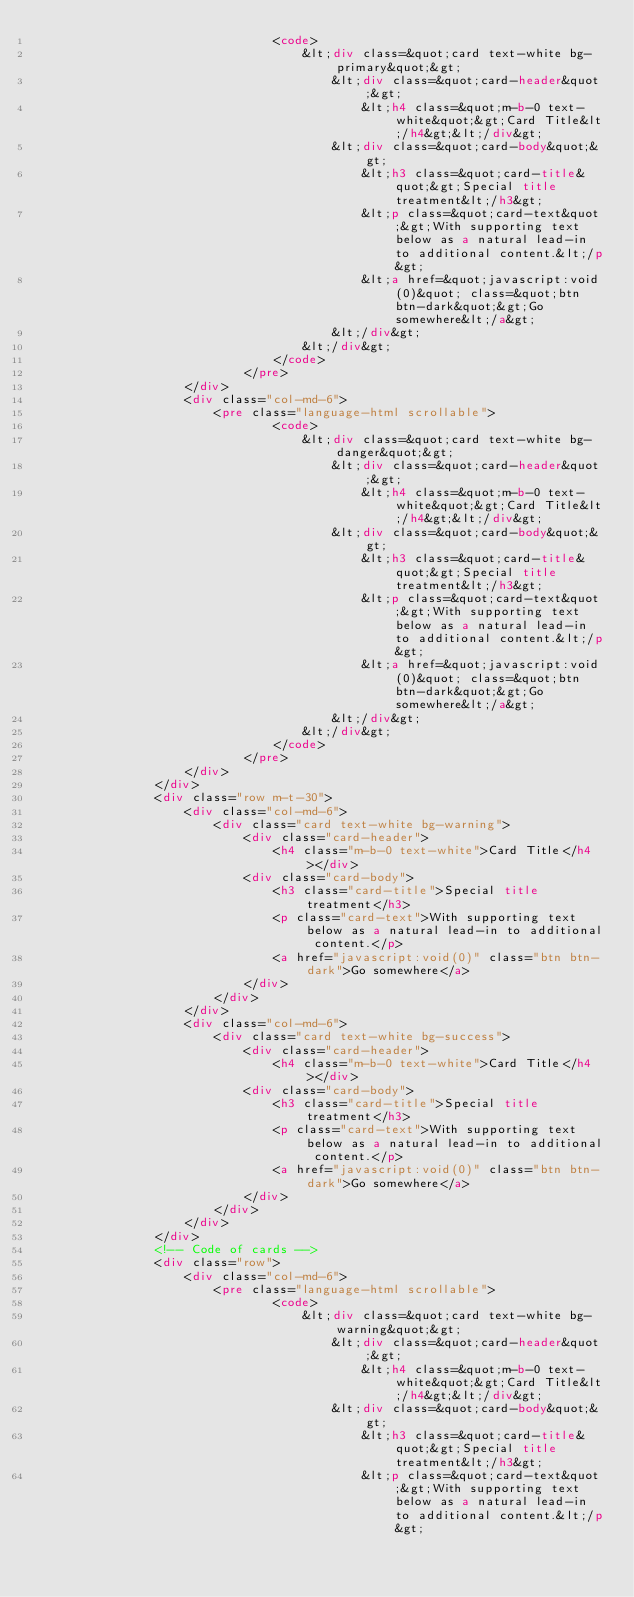Convert code to text. <code><loc_0><loc_0><loc_500><loc_500><_HTML_>                                <code>
                                    &lt;div class=&quot;card text-white bg-primary&quot;&gt;
                                        &lt;div class=&quot;card-header&quot;&gt;
                                            &lt;h4 class=&quot;m-b-0 text-white&quot;&gt;Card Title&lt;/h4&gt;&lt;/div&gt;
                                        &lt;div class=&quot;card-body&quot;&gt;
                                            &lt;h3 class=&quot;card-title&quot;&gt;Special title treatment&lt;/h3&gt;
                                            &lt;p class=&quot;card-text&quot;&gt;With supporting text below as a natural lead-in to additional content.&lt;/p&gt;
                                            &lt;a href=&quot;javascript:void(0)&quot; class=&quot;btn btn-dark&quot;&gt;Go somewhere&lt;/a&gt;
                                        &lt;/div&gt;
                                    &lt;/div&gt;
                                </code>
                            </pre>
                    </div>
                    <div class="col-md-6">
                        <pre class="language-html scrollable">
                                <code>
                                    &lt;div class=&quot;card text-white bg-danger&quot;&gt;
                                        &lt;div class=&quot;card-header&quot;&gt;
                                            &lt;h4 class=&quot;m-b-0 text-white&quot;&gt;Card Title&lt;/h4&gt;&lt;/div&gt;
                                        &lt;div class=&quot;card-body&quot;&gt;
                                            &lt;h3 class=&quot;card-title&quot;&gt;Special title treatment&lt;/h3&gt;
                                            &lt;p class=&quot;card-text&quot;&gt;With supporting text below as a natural lead-in to additional content.&lt;/p&gt;
                                            &lt;a href=&quot;javascript:void(0)&quot; class=&quot;btn btn-dark&quot;&gt;Go somewhere&lt;/a&gt;
                                        &lt;/div&gt;
                                    &lt;/div&gt;
                                </code>
                            </pre>
                    </div>
                </div>
                <div class="row m-t-30">
                    <div class="col-md-6">
                        <div class="card text-white bg-warning">
                            <div class="card-header">
                                <h4 class="m-b-0 text-white">Card Title</h4></div>
                            <div class="card-body">
                                <h3 class="card-title">Special title treatment</h3>
                                <p class="card-text">With supporting text below as a natural lead-in to additional content.</p>
                                <a href="javascript:void(0)" class="btn btn-dark">Go somewhere</a>
                            </div>
                        </div>
                    </div>
                    <div class="col-md-6">
                        <div class="card text-white bg-success">
                            <div class="card-header">
                                <h4 class="m-b-0 text-white">Card Title</h4></div>
                            <div class="card-body">
                                <h3 class="card-title">Special title treatment</h3>
                                <p class="card-text">With supporting text below as a natural lead-in to additional content.</p>
                                <a href="javascript:void(0)" class="btn btn-dark">Go somewhere</a>
                            </div>
                        </div>
                    </div>
                </div>
                <!-- Code of cards -->
                <div class="row">
                    <div class="col-md-6">
                        <pre class="language-html scrollable">
                                <code>
                                    &lt;div class=&quot;card text-white bg-warning&quot;&gt;
                                        &lt;div class=&quot;card-header&quot;&gt;
                                            &lt;h4 class=&quot;m-b-0 text-white&quot;&gt;Card Title&lt;/h4&gt;&lt;/div&gt;
                                        &lt;div class=&quot;card-body&quot;&gt;
                                            &lt;h3 class=&quot;card-title&quot;&gt;Special title treatment&lt;/h3&gt;
                                            &lt;p class=&quot;card-text&quot;&gt;With supporting text below as a natural lead-in to additional content.&lt;/p&gt;</code> 